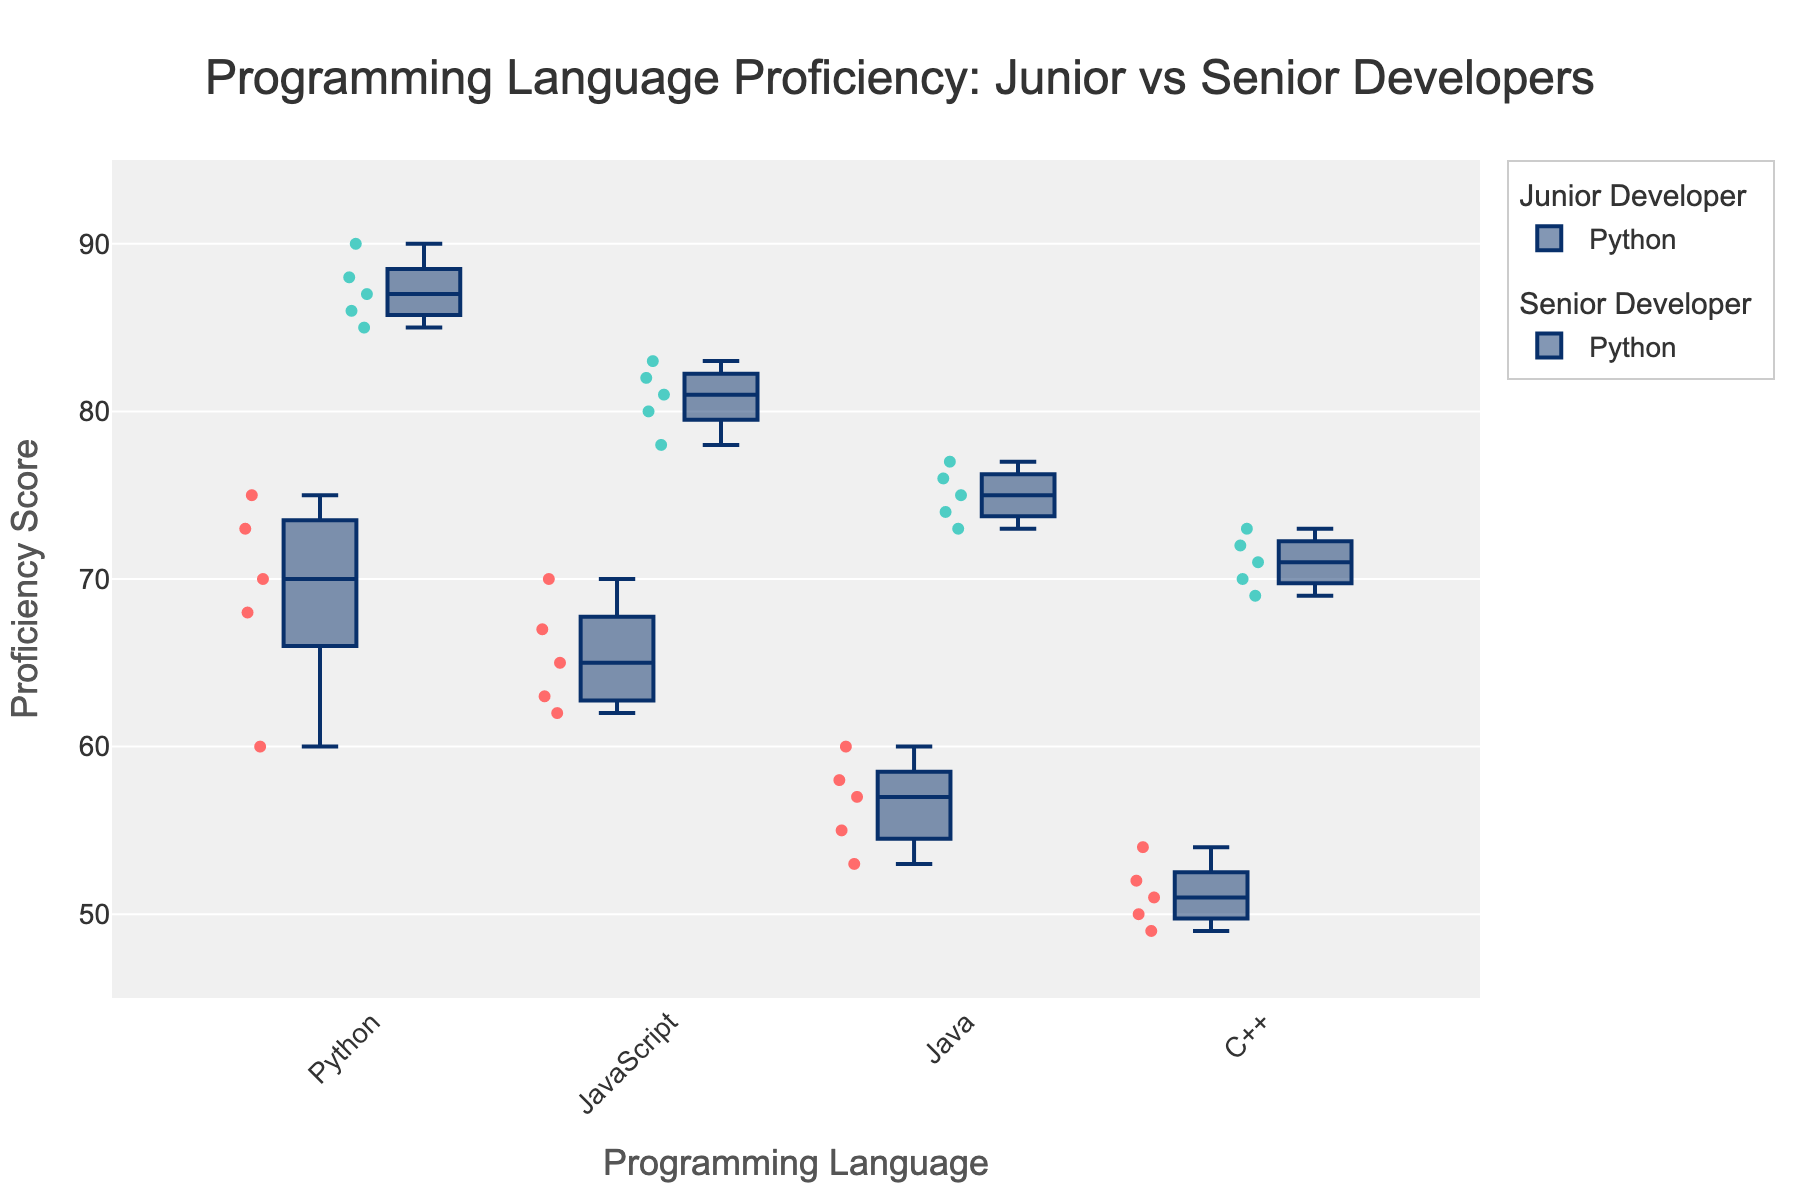What is the title of the plot? The title is displayed prominently at the top of the plot. The title reads "Programming Language Proficiency: Junior vs Senior Developers".
Answer: Programming Language Proficiency: Junior vs Senior Developers Which programming languages are compared in the plot? The plot has separate box plots for each programming language under both Junior and Senior Developers. The languages displayed are Python, JavaScript, Java, and C++.
Answer: Python, JavaScript, Java, C++ What is the highest proficiency score among Senior Developers for Python? To find the highest proficiency score, look at the top point of the box plot for Python under Senior Developers. The highest point is at a score of 90.
Answer: 90 What is the median proficiency score for Junior Developers in C++? The median score is represented by the line inside the box in the C++ box plot for Junior Developers. The median score is around 51.
Answer: 51 How do the median proficiency scores for Python compare between Junior and Senior Developers? Check the lines inside the Python box plots for both Junior and Senior Developers. The median for Junior Developers is about 70, while for Senior Developers, it is around 87. Senior Developers have a higher median.
Answer: Senior Developers have a higher median Which group has a higher average proficiency in JavaScript, Junior or Senior Developers? By observing the centers of the box plots (notches if present) or by estimating the midpoints of the data points, it appears that the Senior Developers have a higher average proficiency in JavaScript compared to Junior Developers.
Answer: Senior Developers For Java, what is the interquartile range (IQR) of proficiency scores for both Junior and Senior Developers? The IQR is the range between the first quartile (Q1) and the third quartile (Q3). For Junior Developers, Q1 is around 55 and Q3 is around 58. For Senior Developers, Q1 is around 73 and Q3 is around 76. So, the IQR for Junior Developers is 3 (58-55) and for Senior Developers is 3 (76-73).
Answer: Both 3 What are the outliers for Junior Developers in C++? Outliers are typically shown as points beyond the whiskers of the box plots. For Junior Developers in C++, there is one outlier at around 49.
Answer: 49 Which programming language shows the largest difference in median proficiency scores between Junior and Senior Developers? Compare the medians (lines inside the boxes) for each language. Python shows the largest difference, with Junior Developers around 70 and Senior Developers around 87.
Answer: Python Based on the plot, which job title shows a more consistent proficiency in JavaScript? Consistency is indicated by the spread of the box plot. The box plot for Senior Developers in JavaScript is less spread out (narrower) than that for Junior Developers, implying higher consistency in proficiency.
Answer: Senior Developers 